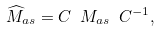<formula> <loc_0><loc_0><loc_500><loc_500>\widehat { M } _ { a s } = C \ M _ { a s } \ { C } ^ { - 1 } ,</formula> 